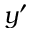<formula> <loc_0><loc_0><loc_500><loc_500>y ^ { \prime }</formula> 